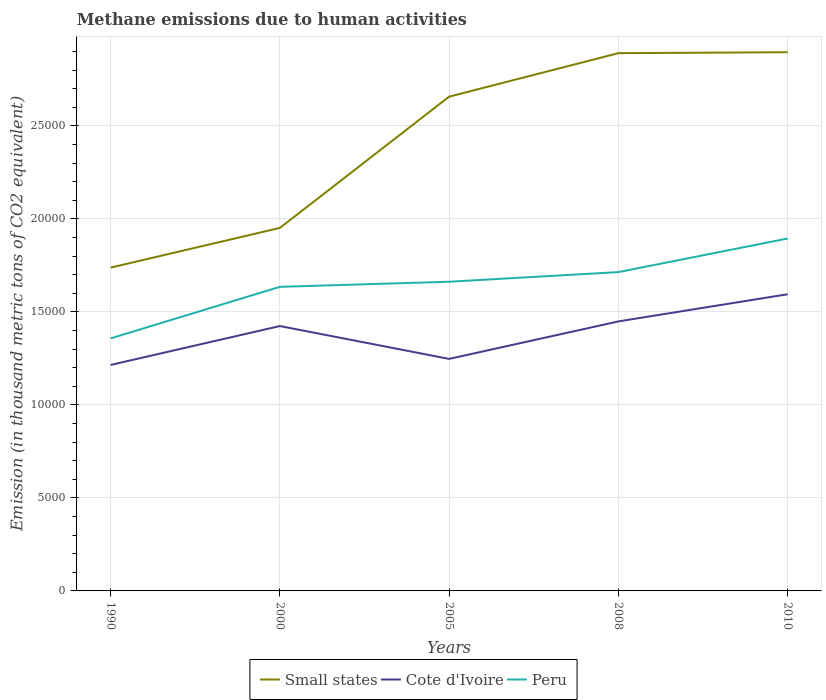How many different coloured lines are there?
Ensure brevity in your answer.  3. Does the line corresponding to Cote d'Ivoire intersect with the line corresponding to Peru?
Your response must be concise. No. Across all years, what is the maximum amount of methane emitted in Cote d'Ivoire?
Make the answer very short. 1.21e+04. What is the total amount of methane emitted in Cote d'Ivoire in the graph?
Offer a very short reply. -325.2. What is the difference between the highest and the second highest amount of methane emitted in Small states?
Provide a succinct answer. 1.16e+04. How many lines are there?
Provide a succinct answer. 3. What is the difference between two consecutive major ticks on the Y-axis?
Your answer should be very brief. 5000. Are the values on the major ticks of Y-axis written in scientific E-notation?
Ensure brevity in your answer.  No. How many legend labels are there?
Your response must be concise. 3. What is the title of the graph?
Make the answer very short. Methane emissions due to human activities. Does "Caribbean small states" appear as one of the legend labels in the graph?
Offer a terse response. No. What is the label or title of the X-axis?
Give a very brief answer. Years. What is the label or title of the Y-axis?
Keep it short and to the point. Emission (in thousand metric tons of CO2 equivalent). What is the Emission (in thousand metric tons of CO2 equivalent) of Small states in 1990?
Make the answer very short. 1.74e+04. What is the Emission (in thousand metric tons of CO2 equivalent) of Cote d'Ivoire in 1990?
Keep it short and to the point. 1.21e+04. What is the Emission (in thousand metric tons of CO2 equivalent) in Peru in 1990?
Provide a succinct answer. 1.36e+04. What is the Emission (in thousand metric tons of CO2 equivalent) of Small states in 2000?
Ensure brevity in your answer.  1.95e+04. What is the Emission (in thousand metric tons of CO2 equivalent) of Cote d'Ivoire in 2000?
Offer a terse response. 1.42e+04. What is the Emission (in thousand metric tons of CO2 equivalent) of Peru in 2000?
Offer a terse response. 1.63e+04. What is the Emission (in thousand metric tons of CO2 equivalent) in Small states in 2005?
Your answer should be compact. 2.66e+04. What is the Emission (in thousand metric tons of CO2 equivalent) of Cote d'Ivoire in 2005?
Your answer should be compact. 1.25e+04. What is the Emission (in thousand metric tons of CO2 equivalent) of Peru in 2005?
Give a very brief answer. 1.66e+04. What is the Emission (in thousand metric tons of CO2 equivalent) of Small states in 2008?
Your answer should be compact. 2.89e+04. What is the Emission (in thousand metric tons of CO2 equivalent) of Cote d'Ivoire in 2008?
Your answer should be compact. 1.45e+04. What is the Emission (in thousand metric tons of CO2 equivalent) of Peru in 2008?
Offer a terse response. 1.71e+04. What is the Emission (in thousand metric tons of CO2 equivalent) in Small states in 2010?
Offer a terse response. 2.90e+04. What is the Emission (in thousand metric tons of CO2 equivalent) of Cote d'Ivoire in 2010?
Ensure brevity in your answer.  1.59e+04. What is the Emission (in thousand metric tons of CO2 equivalent) of Peru in 2010?
Provide a short and direct response. 1.89e+04. Across all years, what is the maximum Emission (in thousand metric tons of CO2 equivalent) of Small states?
Make the answer very short. 2.90e+04. Across all years, what is the maximum Emission (in thousand metric tons of CO2 equivalent) of Cote d'Ivoire?
Provide a short and direct response. 1.59e+04. Across all years, what is the maximum Emission (in thousand metric tons of CO2 equivalent) in Peru?
Ensure brevity in your answer.  1.89e+04. Across all years, what is the minimum Emission (in thousand metric tons of CO2 equivalent) of Small states?
Your response must be concise. 1.74e+04. Across all years, what is the minimum Emission (in thousand metric tons of CO2 equivalent) in Cote d'Ivoire?
Your response must be concise. 1.21e+04. Across all years, what is the minimum Emission (in thousand metric tons of CO2 equivalent) in Peru?
Give a very brief answer. 1.36e+04. What is the total Emission (in thousand metric tons of CO2 equivalent) of Small states in the graph?
Your answer should be very brief. 1.21e+05. What is the total Emission (in thousand metric tons of CO2 equivalent) in Cote d'Ivoire in the graph?
Keep it short and to the point. 6.93e+04. What is the total Emission (in thousand metric tons of CO2 equivalent) of Peru in the graph?
Keep it short and to the point. 8.26e+04. What is the difference between the Emission (in thousand metric tons of CO2 equivalent) of Small states in 1990 and that in 2000?
Offer a terse response. -2132.9. What is the difference between the Emission (in thousand metric tons of CO2 equivalent) of Cote d'Ivoire in 1990 and that in 2000?
Ensure brevity in your answer.  -2090.5. What is the difference between the Emission (in thousand metric tons of CO2 equivalent) of Peru in 1990 and that in 2000?
Keep it short and to the point. -2771.4. What is the difference between the Emission (in thousand metric tons of CO2 equivalent) of Small states in 1990 and that in 2005?
Your answer should be very brief. -9189.8. What is the difference between the Emission (in thousand metric tons of CO2 equivalent) in Cote d'Ivoire in 1990 and that in 2005?
Provide a succinct answer. -325.2. What is the difference between the Emission (in thousand metric tons of CO2 equivalent) in Peru in 1990 and that in 2005?
Your answer should be very brief. -3045.3. What is the difference between the Emission (in thousand metric tons of CO2 equivalent) in Small states in 1990 and that in 2008?
Your answer should be compact. -1.15e+04. What is the difference between the Emission (in thousand metric tons of CO2 equivalent) in Cote d'Ivoire in 1990 and that in 2008?
Keep it short and to the point. -2340.3. What is the difference between the Emission (in thousand metric tons of CO2 equivalent) in Peru in 1990 and that in 2008?
Your response must be concise. -3562.7. What is the difference between the Emission (in thousand metric tons of CO2 equivalent) of Small states in 1990 and that in 2010?
Give a very brief answer. -1.16e+04. What is the difference between the Emission (in thousand metric tons of CO2 equivalent) of Cote d'Ivoire in 1990 and that in 2010?
Offer a terse response. -3800.5. What is the difference between the Emission (in thousand metric tons of CO2 equivalent) in Peru in 1990 and that in 2010?
Keep it short and to the point. -5369.2. What is the difference between the Emission (in thousand metric tons of CO2 equivalent) in Small states in 2000 and that in 2005?
Offer a terse response. -7056.9. What is the difference between the Emission (in thousand metric tons of CO2 equivalent) in Cote d'Ivoire in 2000 and that in 2005?
Provide a short and direct response. 1765.3. What is the difference between the Emission (in thousand metric tons of CO2 equivalent) in Peru in 2000 and that in 2005?
Provide a short and direct response. -273.9. What is the difference between the Emission (in thousand metric tons of CO2 equivalent) of Small states in 2000 and that in 2008?
Give a very brief answer. -9393.1. What is the difference between the Emission (in thousand metric tons of CO2 equivalent) in Cote d'Ivoire in 2000 and that in 2008?
Your answer should be very brief. -249.8. What is the difference between the Emission (in thousand metric tons of CO2 equivalent) of Peru in 2000 and that in 2008?
Offer a terse response. -791.3. What is the difference between the Emission (in thousand metric tons of CO2 equivalent) in Small states in 2000 and that in 2010?
Provide a succinct answer. -9444.8. What is the difference between the Emission (in thousand metric tons of CO2 equivalent) of Cote d'Ivoire in 2000 and that in 2010?
Your answer should be very brief. -1710. What is the difference between the Emission (in thousand metric tons of CO2 equivalent) in Peru in 2000 and that in 2010?
Your response must be concise. -2597.8. What is the difference between the Emission (in thousand metric tons of CO2 equivalent) of Small states in 2005 and that in 2008?
Make the answer very short. -2336.2. What is the difference between the Emission (in thousand metric tons of CO2 equivalent) in Cote d'Ivoire in 2005 and that in 2008?
Keep it short and to the point. -2015.1. What is the difference between the Emission (in thousand metric tons of CO2 equivalent) in Peru in 2005 and that in 2008?
Keep it short and to the point. -517.4. What is the difference between the Emission (in thousand metric tons of CO2 equivalent) in Small states in 2005 and that in 2010?
Make the answer very short. -2387.9. What is the difference between the Emission (in thousand metric tons of CO2 equivalent) of Cote d'Ivoire in 2005 and that in 2010?
Ensure brevity in your answer.  -3475.3. What is the difference between the Emission (in thousand metric tons of CO2 equivalent) in Peru in 2005 and that in 2010?
Give a very brief answer. -2323.9. What is the difference between the Emission (in thousand metric tons of CO2 equivalent) in Small states in 2008 and that in 2010?
Your answer should be very brief. -51.7. What is the difference between the Emission (in thousand metric tons of CO2 equivalent) of Cote d'Ivoire in 2008 and that in 2010?
Your answer should be very brief. -1460.2. What is the difference between the Emission (in thousand metric tons of CO2 equivalent) in Peru in 2008 and that in 2010?
Offer a very short reply. -1806.5. What is the difference between the Emission (in thousand metric tons of CO2 equivalent) in Small states in 1990 and the Emission (in thousand metric tons of CO2 equivalent) in Cote d'Ivoire in 2000?
Keep it short and to the point. 3141.9. What is the difference between the Emission (in thousand metric tons of CO2 equivalent) in Small states in 1990 and the Emission (in thousand metric tons of CO2 equivalent) in Peru in 2000?
Make the answer very short. 1033.6. What is the difference between the Emission (in thousand metric tons of CO2 equivalent) of Cote d'Ivoire in 1990 and the Emission (in thousand metric tons of CO2 equivalent) of Peru in 2000?
Offer a terse response. -4198.8. What is the difference between the Emission (in thousand metric tons of CO2 equivalent) in Small states in 1990 and the Emission (in thousand metric tons of CO2 equivalent) in Cote d'Ivoire in 2005?
Make the answer very short. 4907.2. What is the difference between the Emission (in thousand metric tons of CO2 equivalent) in Small states in 1990 and the Emission (in thousand metric tons of CO2 equivalent) in Peru in 2005?
Ensure brevity in your answer.  759.7. What is the difference between the Emission (in thousand metric tons of CO2 equivalent) of Cote d'Ivoire in 1990 and the Emission (in thousand metric tons of CO2 equivalent) of Peru in 2005?
Offer a terse response. -4472.7. What is the difference between the Emission (in thousand metric tons of CO2 equivalent) of Small states in 1990 and the Emission (in thousand metric tons of CO2 equivalent) of Cote d'Ivoire in 2008?
Ensure brevity in your answer.  2892.1. What is the difference between the Emission (in thousand metric tons of CO2 equivalent) in Small states in 1990 and the Emission (in thousand metric tons of CO2 equivalent) in Peru in 2008?
Offer a terse response. 242.3. What is the difference between the Emission (in thousand metric tons of CO2 equivalent) in Cote d'Ivoire in 1990 and the Emission (in thousand metric tons of CO2 equivalent) in Peru in 2008?
Your answer should be compact. -4990.1. What is the difference between the Emission (in thousand metric tons of CO2 equivalent) of Small states in 1990 and the Emission (in thousand metric tons of CO2 equivalent) of Cote d'Ivoire in 2010?
Offer a very short reply. 1431.9. What is the difference between the Emission (in thousand metric tons of CO2 equivalent) of Small states in 1990 and the Emission (in thousand metric tons of CO2 equivalent) of Peru in 2010?
Give a very brief answer. -1564.2. What is the difference between the Emission (in thousand metric tons of CO2 equivalent) in Cote d'Ivoire in 1990 and the Emission (in thousand metric tons of CO2 equivalent) in Peru in 2010?
Give a very brief answer. -6796.6. What is the difference between the Emission (in thousand metric tons of CO2 equivalent) of Small states in 2000 and the Emission (in thousand metric tons of CO2 equivalent) of Cote d'Ivoire in 2005?
Give a very brief answer. 7040.1. What is the difference between the Emission (in thousand metric tons of CO2 equivalent) of Small states in 2000 and the Emission (in thousand metric tons of CO2 equivalent) of Peru in 2005?
Offer a very short reply. 2892.6. What is the difference between the Emission (in thousand metric tons of CO2 equivalent) of Cote d'Ivoire in 2000 and the Emission (in thousand metric tons of CO2 equivalent) of Peru in 2005?
Offer a terse response. -2382.2. What is the difference between the Emission (in thousand metric tons of CO2 equivalent) in Small states in 2000 and the Emission (in thousand metric tons of CO2 equivalent) in Cote d'Ivoire in 2008?
Offer a very short reply. 5025. What is the difference between the Emission (in thousand metric tons of CO2 equivalent) of Small states in 2000 and the Emission (in thousand metric tons of CO2 equivalent) of Peru in 2008?
Ensure brevity in your answer.  2375.2. What is the difference between the Emission (in thousand metric tons of CO2 equivalent) in Cote d'Ivoire in 2000 and the Emission (in thousand metric tons of CO2 equivalent) in Peru in 2008?
Your response must be concise. -2899.6. What is the difference between the Emission (in thousand metric tons of CO2 equivalent) in Small states in 2000 and the Emission (in thousand metric tons of CO2 equivalent) in Cote d'Ivoire in 2010?
Keep it short and to the point. 3564.8. What is the difference between the Emission (in thousand metric tons of CO2 equivalent) in Small states in 2000 and the Emission (in thousand metric tons of CO2 equivalent) in Peru in 2010?
Give a very brief answer. 568.7. What is the difference between the Emission (in thousand metric tons of CO2 equivalent) of Cote d'Ivoire in 2000 and the Emission (in thousand metric tons of CO2 equivalent) of Peru in 2010?
Your answer should be very brief. -4706.1. What is the difference between the Emission (in thousand metric tons of CO2 equivalent) of Small states in 2005 and the Emission (in thousand metric tons of CO2 equivalent) of Cote d'Ivoire in 2008?
Offer a very short reply. 1.21e+04. What is the difference between the Emission (in thousand metric tons of CO2 equivalent) of Small states in 2005 and the Emission (in thousand metric tons of CO2 equivalent) of Peru in 2008?
Provide a short and direct response. 9432.1. What is the difference between the Emission (in thousand metric tons of CO2 equivalent) in Cote d'Ivoire in 2005 and the Emission (in thousand metric tons of CO2 equivalent) in Peru in 2008?
Your answer should be compact. -4664.9. What is the difference between the Emission (in thousand metric tons of CO2 equivalent) of Small states in 2005 and the Emission (in thousand metric tons of CO2 equivalent) of Cote d'Ivoire in 2010?
Your answer should be compact. 1.06e+04. What is the difference between the Emission (in thousand metric tons of CO2 equivalent) of Small states in 2005 and the Emission (in thousand metric tons of CO2 equivalent) of Peru in 2010?
Offer a very short reply. 7625.6. What is the difference between the Emission (in thousand metric tons of CO2 equivalent) in Cote d'Ivoire in 2005 and the Emission (in thousand metric tons of CO2 equivalent) in Peru in 2010?
Your response must be concise. -6471.4. What is the difference between the Emission (in thousand metric tons of CO2 equivalent) in Small states in 2008 and the Emission (in thousand metric tons of CO2 equivalent) in Cote d'Ivoire in 2010?
Ensure brevity in your answer.  1.30e+04. What is the difference between the Emission (in thousand metric tons of CO2 equivalent) in Small states in 2008 and the Emission (in thousand metric tons of CO2 equivalent) in Peru in 2010?
Make the answer very short. 9961.8. What is the difference between the Emission (in thousand metric tons of CO2 equivalent) in Cote d'Ivoire in 2008 and the Emission (in thousand metric tons of CO2 equivalent) in Peru in 2010?
Your response must be concise. -4456.3. What is the average Emission (in thousand metric tons of CO2 equivalent) of Small states per year?
Your answer should be very brief. 2.43e+04. What is the average Emission (in thousand metric tons of CO2 equivalent) in Cote d'Ivoire per year?
Offer a very short reply. 1.39e+04. What is the average Emission (in thousand metric tons of CO2 equivalent) of Peru per year?
Keep it short and to the point. 1.65e+04. In the year 1990, what is the difference between the Emission (in thousand metric tons of CO2 equivalent) of Small states and Emission (in thousand metric tons of CO2 equivalent) of Cote d'Ivoire?
Keep it short and to the point. 5232.4. In the year 1990, what is the difference between the Emission (in thousand metric tons of CO2 equivalent) in Small states and Emission (in thousand metric tons of CO2 equivalent) in Peru?
Make the answer very short. 3805. In the year 1990, what is the difference between the Emission (in thousand metric tons of CO2 equivalent) of Cote d'Ivoire and Emission (in thousand metric tons of CO2 equivalent) of Peru?
Your response must be concise. -1427.4. In the year 2000, what is the difference between the Emission (in thousand metric tons of CO2 equivalent) in Small states and Emission (in thousand metric tons of CO2 equivalent) in Cote d'Ivoire?
Your answer should be very brief. 5274.8. In the year 2000, what is the difference between the Emission (in thousand metric tons of CO2 equivalent) in Small states and Emission (in thousand metric tons of CO2 equivalent) in Peru?
Provide a short and direct response. 3166.5. In the year 2000, what is the difference between the Emission (in thousand metric tons of CO2 equivalent) in Cote d'Ivoire and Emission (in thousand metric tons of CO2 equivalent) in Peru?
Ensure brevity in your answer.  -2108.3. In the year 2005, what is the difference between the Emission (in thousand metric tons of CO2 equivalent) in Small states and Emission (in thousand metric tons of CO2 equivalent) in Cote d'Ivoire?
Ensure brevity in your answer.  1.41e+04. In the year 2005, what is the difference between the Emission (in thousand metric tons of CO2 equivalent) of Small states and Emission (in thousand metric tons of CO2 equivalent) of Peru?
Give a very brief answer. 9949.5. In the year 2005, what is the difference between the Emission (in thousand metric tons of CO2 equivalent) in Cote d'Ivoire and Emission (in thousand metric tons of CO2 equivalent) in Peru?
Give a very brief answer. -4147.5. In the year 2008, what is the difference between the Emission (in thousand metric tons of CO2 equivalent) in Small states and Emission (in thousand metric tons of CO2 equivalent) in Cote d'Ivoire?
Keep it short and to the point. 1.44e+04. In the year 2008, what is the difference between the Emission (in thousand metric tons of CO2 equivalent) in Small states and Emission (in thousand metric tons of CO2 equivalent) in Peru?
Your response must be concise. 1.18e+04. In the year 2008, what is the difference between the Emission (in thousand metric tons of CO2 equivalent) in Cote d'Ivoire and Emission (in thousand metric tons of CO2 equivalent) in Peru?
Your answer should be very brief. -2649.8. In the year 2010, what is the difference between the Emission (in thousand metric tons of CO2 equivalent) of Small states and Emission (in thousand metric tons of CO2 equivalent) of Cote d'Ivoire?
Your answer should be very brief. 1.30e+04. In the year 2010, what is the difference between the Emission (in thousand metric tons of CO2 equivalent) of Small states and Emission (in thousand metric tons of CO2 equivalent) of Peru?
Give a very brief answer. 1.00e+04. In the year 2010, what is the difference between the Emission (in thousand metric tons of CO2 equivalent) in Cote d'Ivoire and Emission (in thousand metric tons of CO2 equivalent) in Peru?
Make the answer very short. -2996.1. What is the ratio of the Emission (in thousand metric tons of CO2 equivalent) in Small states in 1990 to that in 2000?
Your answer should be very brief. 0.89. What is the ratio of the Emission (in thousand metric tons of CO2 equivalent) of Cote d'Ivoire in 1990 to that in 2000?
Offer a very short reply. 0.85. What is the ratio of the Emission (in thousand metric tons of CO2 equivalent) in Peru in 1990 to that in 2000?
Your answer should be compact. 0.83. What is the ratio of the Emission (in thousand metric tons of CO2 equivalent) of Small states in 1990 to that in 2005?
Provide a short and direct response. 0.65. What is the ratio of the Emission (in thousand metric tons of CO2 equivalent) in Cote d'Ivoire in 1990 to that in 2005?
Your answer should be very brief. 0.97. What is the ratio of the Emission (in thousand metric tons of CO2 equivalent) in Peru in 1990 to that in 2005?
Ensure brevity in your answer.  0.82. What is the ratio of the Emission (in thousand metric tons of CO2 equivalent) of Small states in 1990 to that in 2008?
Give a very brief answer. 0.6. What is the ratio of the Emission (in thousand metric tons of CO2 equivalent) of Cote d'Ivoire in 1990 to that in 2008?
Keep it short and to the point. 0.84. What is the ratio of the Emission (in thousand metric tons of CO2 equivalent) in Peru in 1990 to that in 2008?
Provide a short and direct response. 0.79. What is the ratio of the Emission (in thousand metric tons of CO2 equivalent) of Small states in 1990 to that in 2010?
Give a very brief answer. 0.6. What is the ratio of the Emission (in thousand metric tons of CO2 equivalent) of Cote d'Ivoire in 1990 to that in 2010?
Offer a very short reply. 0.76. What is the ratio of the Emission (in thousand metric tons of CO2 equivalent) in Peru in 1990 to that in 2010?
Provide a short and direct response. 0.72. What is the ratio of the Emission (in thousand metric tons of CO2 equivalent) in Small states in 2000 to that in 2005?
Offer a very short reply. 0.73. What is the ratio of the Emission (in thousand metric tons of CO2 equivalent) in Cote d'Ivoire in 2000 to that in 2005?
Offer a terse response. 1.14. What is the ratio of the Emission (in thousand metric tons of CO2 equivalent) in Peru in 2000 to that in 2005?
Provide a succinct answer. 0.98. What is the ratio of the Emission (in thousand metric tons of CO2 equivalent) of Small states in 2000 to that in 2008?
Give a very brief answer. 0.68. What is the ratio of the Emission (in thousand metric tons of CO2 equivalent) of Cote d'Ivoire in 2000 to that in 2008?
Your answer should be very brief. 0.98. What is the ratio of the Emission (in thousand metric tons of CO2 equivalent) in Peru in 2000 to that in 2008?
Keep it short and to the point. 0.95. What is the ratio of the Emission (in thousand metric tons of CO2 equivalent) of Small states in 2000 to that in 2010?
Your answer should be very brief. 0.67. What is the ratio of the Emission (in thousand metric tons of CO2 equivalent) in Cote d'Ivoire in 2000 to that in 2010?
Your answer should be very brief. 0.89. What is the ratio of the Emission (in thousand metric tons of CO2 equivalent) in Peru in 2000 to that in 2010?
Your response must be concise. 0.86. What is the ratio of the Emission (in thousand metric tons of CO2 equivalent) of Small states in 2005 to that in 2008?
Offer a terse response. 0.92. What is the ratio of the Emission (in thousand metric tons of CO2 equivalent) in Cote d'Ivoire in 2005 to that in 2008?
Provide a short and direct response. 0.86. What is the ratio of the Emission (in thousand metric tons of CO2 equivalent) of Peru in 2005 to that in 2008?
Your answer should be compact. 0.97. What is the ratio of the Emission (in thousand metric tons of CO2 equivalent) in Small states in 2005 to that in 2010?
Offer a very short reply. 0.92. What is the ratio of the Emission (in thousand metric tons of CO2 equivalent) in Cote d'Ivoire in 2005 to that in 2010?
Offer a very short reply. 0.78. What is the ratio of the Emission (in thousand metric tons of CO2 equivalent) in Peru in 2005 to that in 2010?
Provide a succinct answer. 0.88. What is the ratio of the Emission (in thousand metric tons of CO2 equivalent) in Small states in 2008 to that in 2010?
Ensure brevity in your answer.  1. What is the ratio of the Emission (in thousand metric tons of CO2 equivalent) in Cote d'Ivoire in 2008 to that in 2010?
Your response must be concise. 0.91. What is the ratio of the Emission (in thousand metric tons of CO2 equivalent) of Peru in 2008 to that in 2010?
Offer a terse response. 0.9. What is the difference between the highest and the second highest Emission (in thousand metric tons of CO2 equivalent) of Small states?
Offer a very short reply. 51.7. What is the difference between the highest and the second highest Emission (in thousand metric tons of CO2 equivalent) in Cote d'Ivoire?
Your answer should be compact. 1460.2. What is the difference between the highest and the second highest Emission (in thousand metric tons of CO2 equivalent) in Peru?
Keep it short and to the point. 1806.5. What is the difference between the highest and the lowest Emission (in thousand metric tons of CO2 equivalent) of Small states?
Ensure brevity in your answer.  1.16e+04. What is the difference between the highest and the lowest Emission (in thousand metric tons of CO2 equivalent) in Cote d'Ivoire?
Your answer should be compact. 3800.5. What is the difference between the highest and the lowest Emission (in thousand metric tons of CO2 equivalent) of Peru?
Provide a succinct answer. 5369.2. 